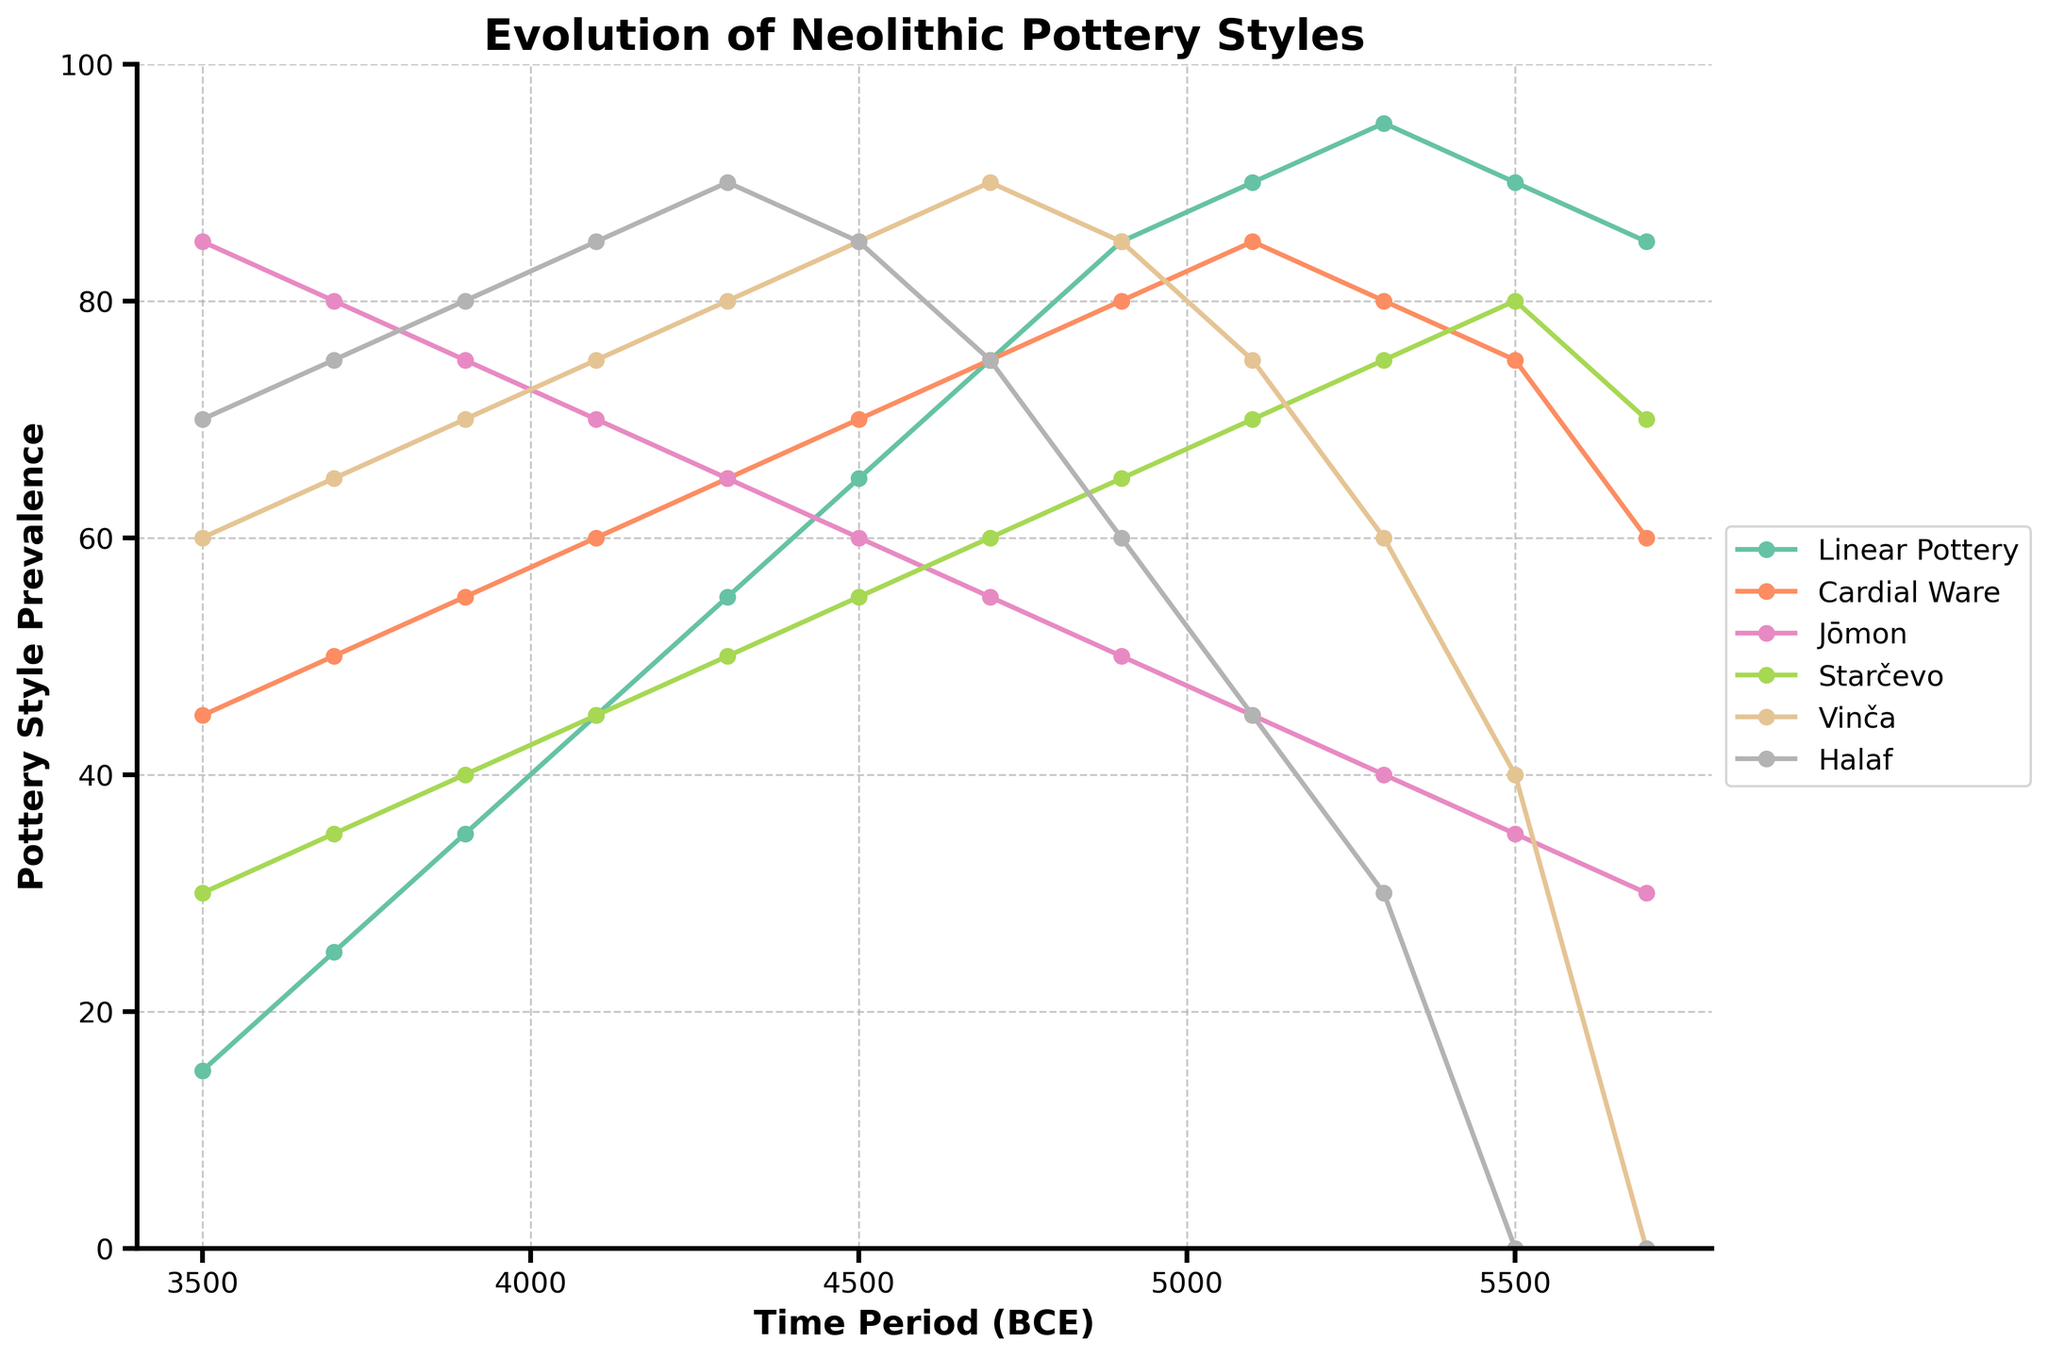What pottery style was most prevalent around 5100 BCE? The chart shows the 'Pottery Style Prevalence' for various styles around 5100 BCE, noted by how high their respective lines are. The one with the highest percentage value at this time period is the most prevalent.
Answer: Halaf Which pottery style experienced the sharpest decline between 5300 BCE and 4700 BCE? To identify the sharpest decline, look for the style that has the maximum drop in prevalence values between the years 5300 BCE and 4700 BCE by visually comparing the slopes of the lines.
Answer: Linear Pottery During which time period did the Jōmon style achieve its peak prevalence? Follow the Jōmon line across the timeline and identify the time period where its prevalence value is the highest.
Answer: 3500 BCE Compare the prevalence of Starčevo and Vinča styles around 4500 BCE. Which one was more prevalent? Check the plotted values for Starčevo and Vinča at 4500 BCE and compare the heights of their respective data points on the y-axis.
Answer: Vinča Which pottery style maintained a constant prevalence between 4500 BCE and 4100 BCE? Look for a style line that remains flat (no slope change) between the years 4500 BCE and 4100 BCE.
Answer: Jōmon Calculate the average prevalence of Linear Pottery between 5700 BCE and 4500 BCE. First sum the prevalence values of Linear Pottery from 5700 BCE to 4500 BCE, then divide the sum by the number of data points (7).\
(85 + 90 + 95 + 90 + 85 + 75 + 65) = 585 / 7 = 83.57
Answer: 83.57 Which pottery styles were not prevalent until after 5500 BCE? Identify styles whose lines start from a non-zero prevalence only after 5500 BCE.
Answer: Vinča, Halaf By how much did the prevalence of Cardial Ware increase from 5700 BCE to 5100 BCE? Subtract the prevalence value of Cardial Ware at 5700 BCE (60) from its value at 5100 BCE (85).\
85 - 60 = 25
Answer: 25 Compare the prevalence of Linear Pottery and Halaf around 4100 BCE. Which one was more prevalent? Check the plotted values for Linear Pottery and Halaf at 4100 BCE and compare the heights of their respective data points on the y-axis.
Answer: Halaf From the chart, determine which pottery style had a prevalence of 60 around 4500 BCE. Follow the horizontal line at prevalence value 60 around the 4500 BCE mark and see which style's plotted line intersects at this point.
Answer: Jōmon 